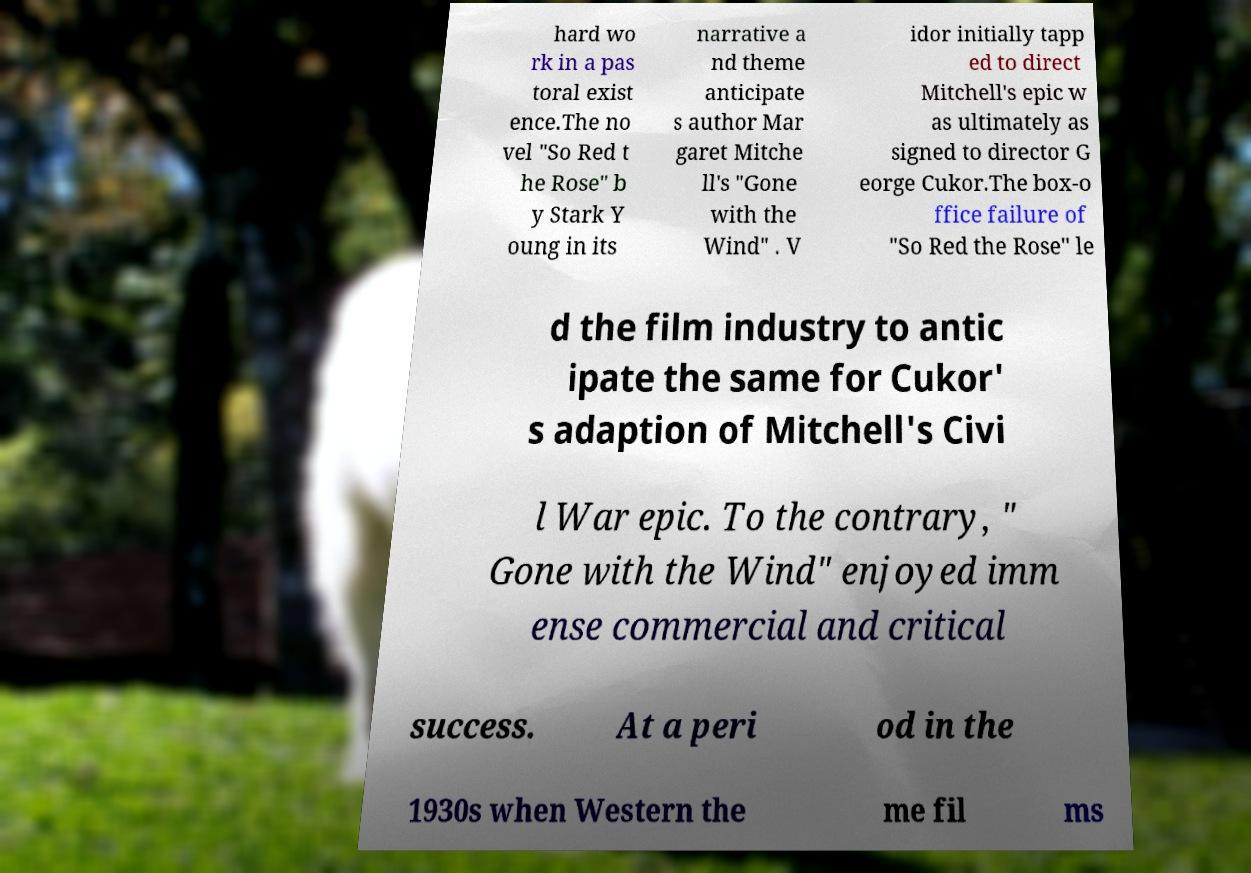I need the written content from this picture converted into text. Can you do that? hard wo rk in a pas toral exist ence.The no vel "So Red t he Rose" b y Stark Y oung in its narrative a nd theme anticipate s author Mar garet Mitche ll's "Gone with the Wind" . V idor initially tapp ed to direct Mitchell's epic w as ultimately as signed to director G eorge Cukor.The box-o ffice failure of "So Red the Rose" le d the film industry to antic ipate the same for Cukor' s adaption of Mitchell's Civi l War epic. To the contrary, " Gone with the Wind" enjoyed imm ense commercial and critical success. At a peri od in the 1930s when Western the me fil ms 